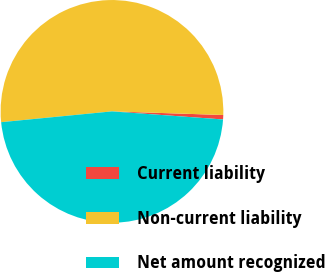Convert chart to OTSL. <chart><loc_0><loc_0><loc_500><loc_500><pie_chart><fcel>Current liability<fcel>Non-current liability<fcel>Net amount recognized<nl><fcel>0.64%<fcel>52.07%<fcel>47.3%<nl></chart> 